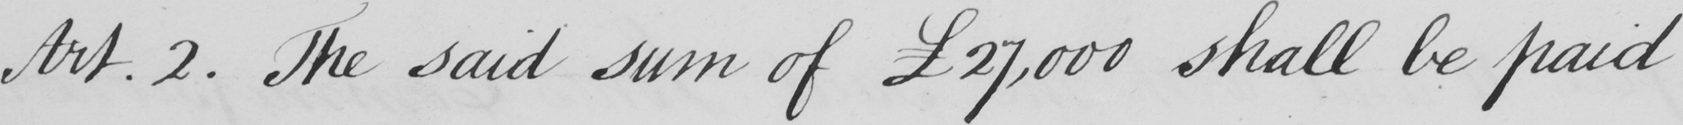Transcribe the text shown in this historical manuscript line. Art.2 . The said sum of  £27,000 shall be paid 